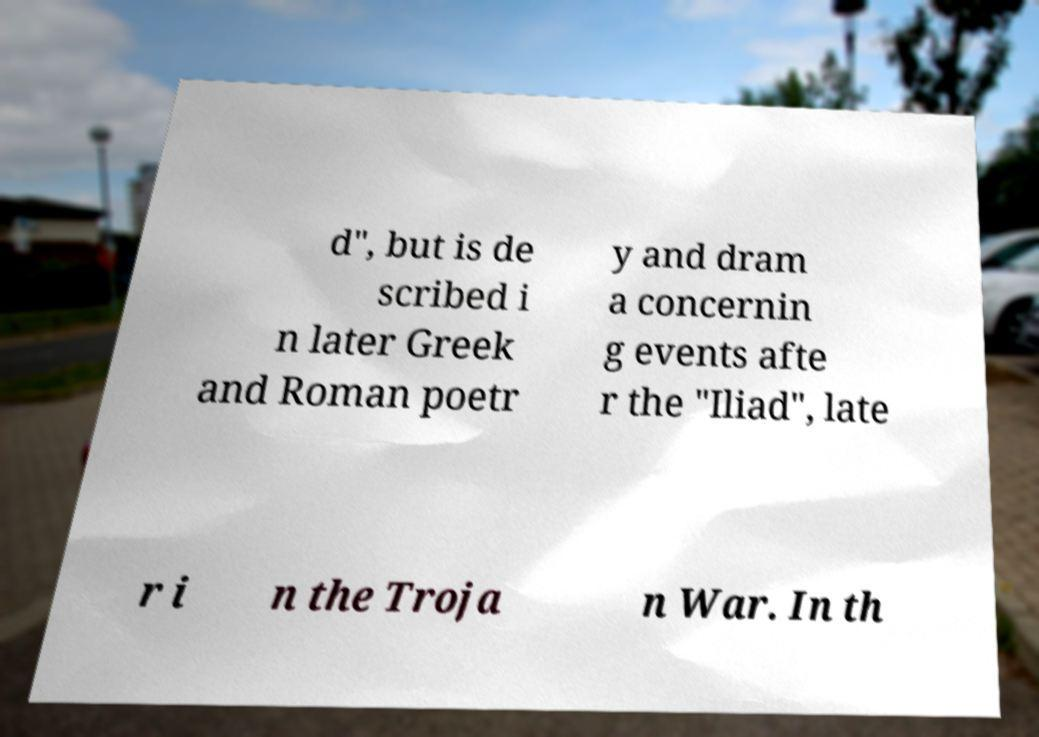Please identify and transcribe the text found in this image. d", but is de scribed i n later Greek and Roman poetr y and dram a concernin g events afte r the "Iliad", late r i n the Troja n War. In th 